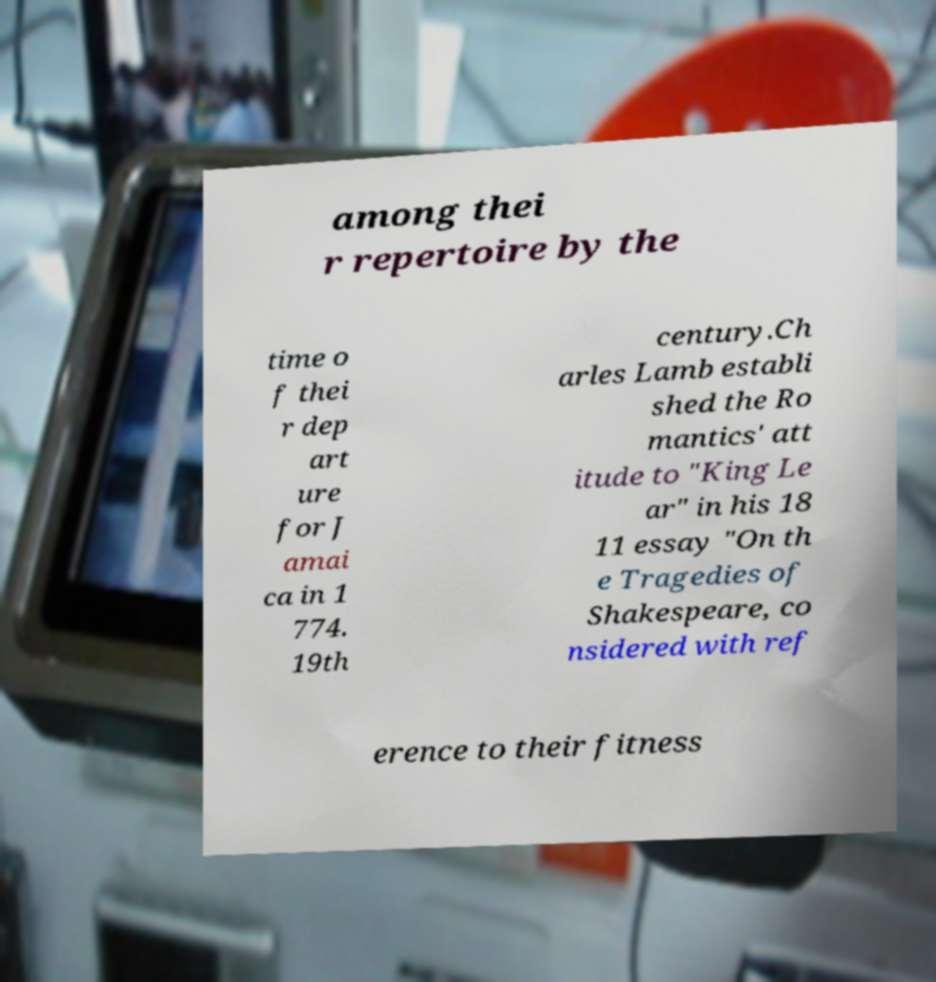Can you read and provide the text displayed in the image?This photo seems to have some interesting text. Can you extract and type it out for me? among thei r repertoire by the time o f thei r dep art ure for J amai ca in 1 774. 19th century.Ch arles Lamb establi shed the Ro mantics' att itude to "King Le ar" in his 18 11 essay "On th e Tragedies of Shakespeare, co nsidered with ref erence to their fitness 